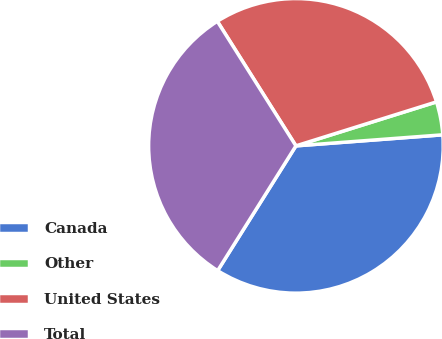Convert chart to OTSL. <chart><loc_0><loc_0><loc_500><loc_500><pie_chart><fcel>Canada<fcel>Other<fcel>United States<fcel>Total<nl><fcel>35.11%<fcel>3.63%<fcel>29.13%<fcel>32.12%<nl></chart> 